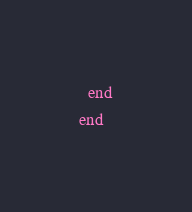Convert code to text. <code><loc_0><loc_0><loc_500><loc_500><_Ruby_>  end
end
</code> 